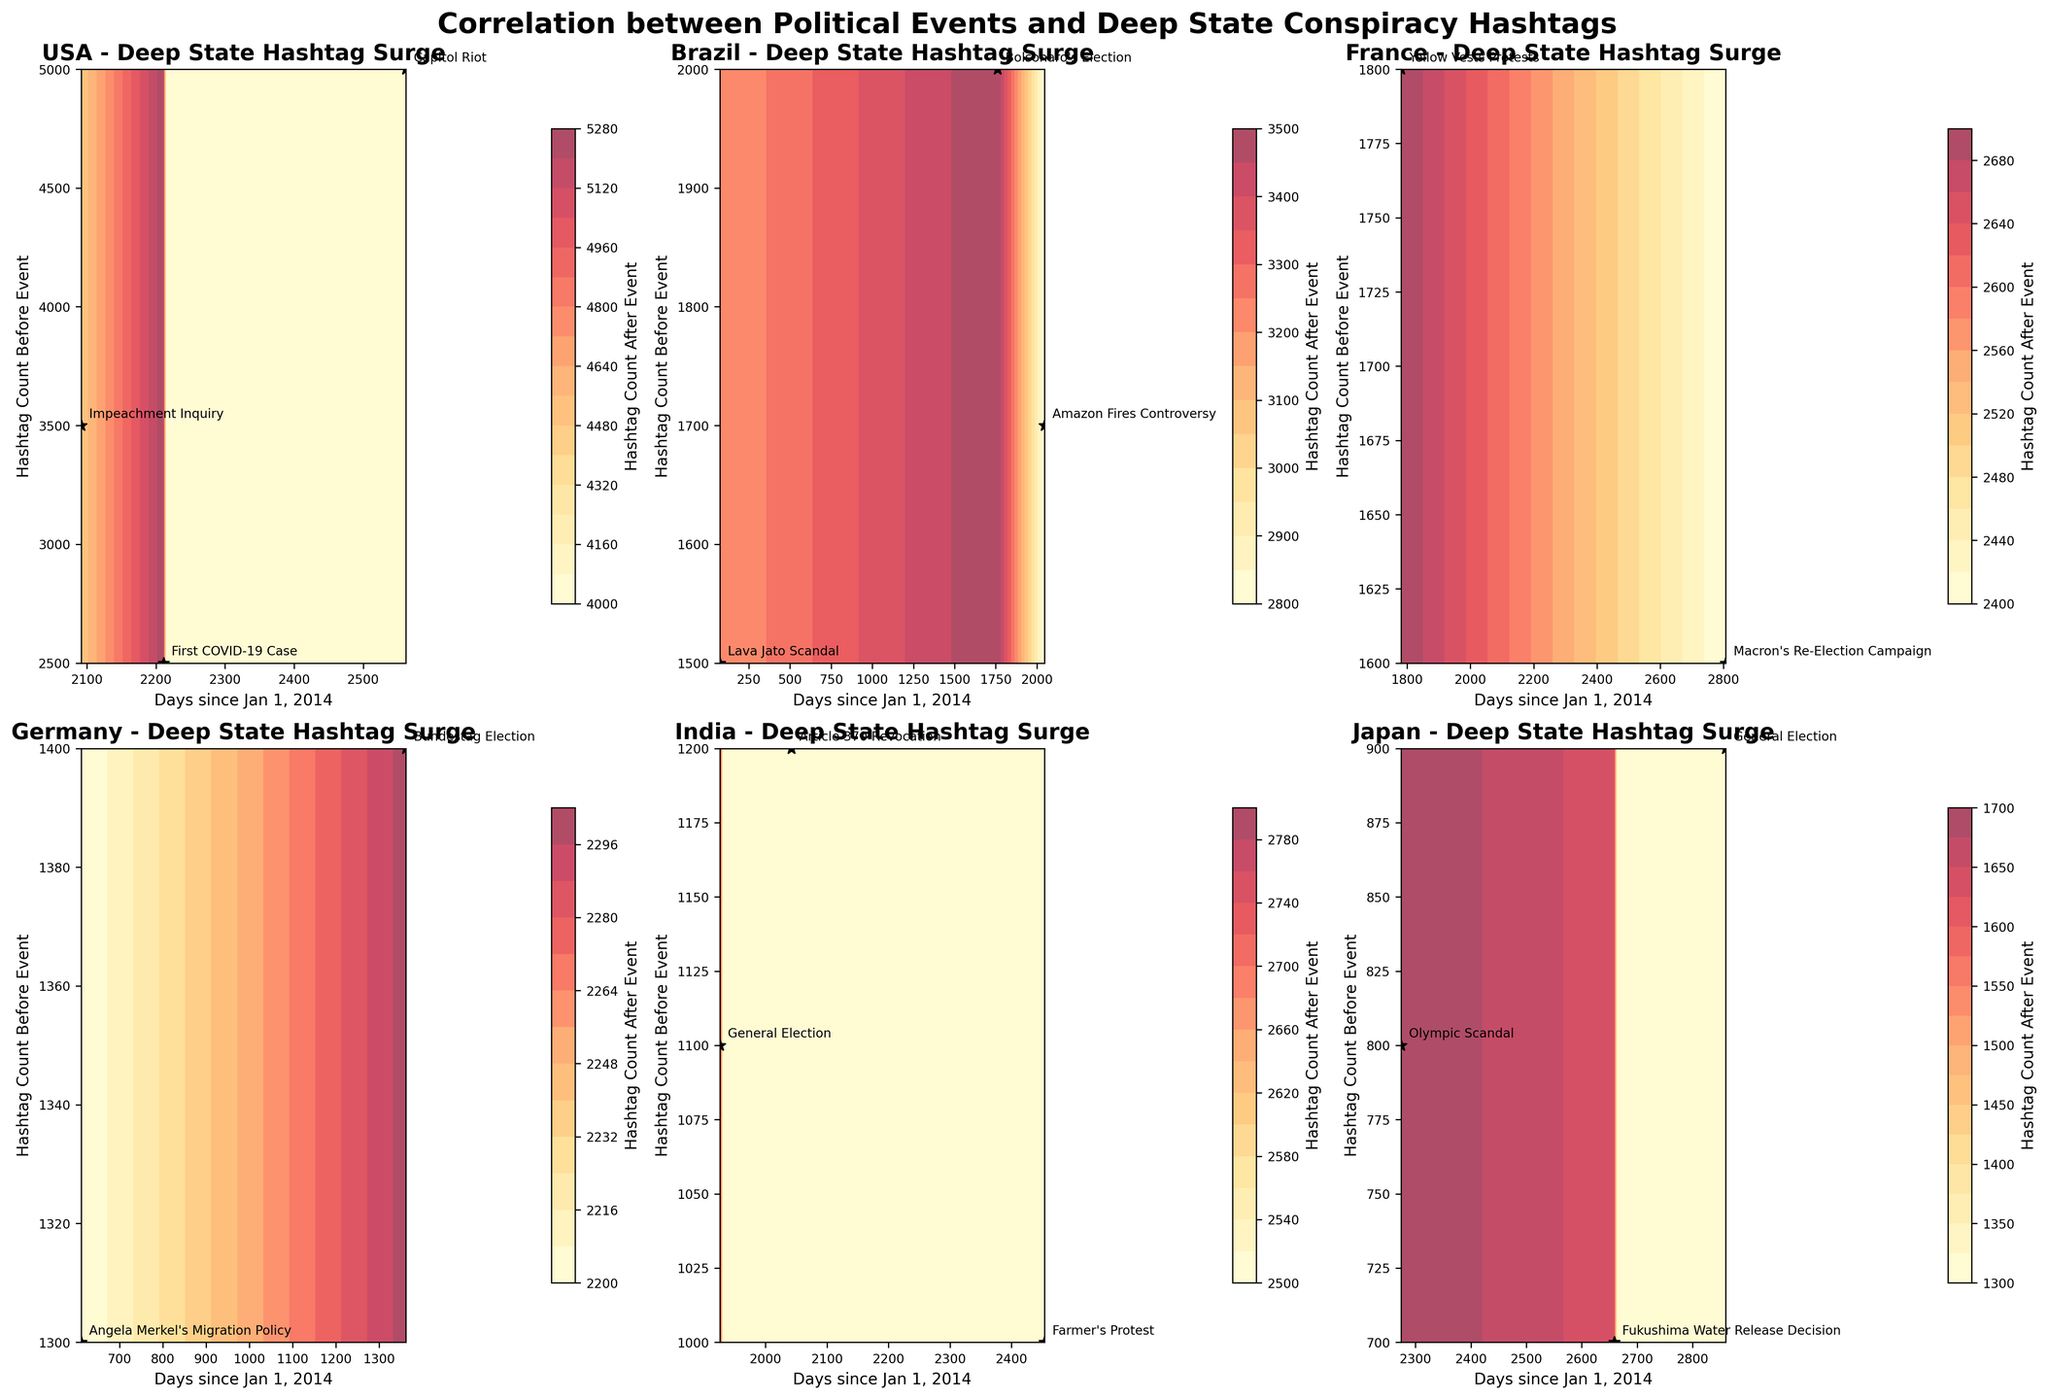How many countries are presented in the figure? The figure contains subplots for each country, and the subplot titles indicate the number of countries analyzed. By counting the titles, we determine how many countries are included.
Answer: 5 Which country shows the highest surge in hashtags after political events? By examining the color bar intensity and the scatter plots across all subplots, the country with the highest concentration of darker colors represents the highest surge in hashtags. The USA shows a significant increase in hashtag counts.
Answer: USA What is the color bar label in the figure? Each contour plot contains a color bar on the side. The label of the color bar indicates what values it represents. By reading the text next to the color bar, we can find the label.
Answer: Hashtag Count After Event Which political event in the USA subplot has the highest initial hashtag count before the event? In the USA subplot, identify the event with the largest y-axis value (Hashtag Count Before Event). The text annotations next to the highest point give the name of the political event.
Answer: Capitol Riot Comparing Brazil and France, which country had a greater range of days since January 1, 2014, when significant political events occurred? By comparing the ranges of the x-axes (Days since Jan 1, 2014) for Brazil and France subplots, the country with wider range of event dates can be determined.
Answer: Brazil What is the title of the figure? The title is located at the top center of the figure. By reading the text in this area, we can identify the title.
Answer: Correlation between Political Events and Deep State Conspiracy Hashtags Identify two countries with similar trends in hashtag counts before and after political events. Examine the contour plots and scatter points for trends where hashtag counts after events are proportionate to the counts before events for various countries. Countries with similar patterns of increases or stable counts before and after events can be identified.
Answer: France and Germany In the subplot for India, which event shows the smallest surge in hashtags after the event? By looking at the annotated political events and the corresponding points on the Y-axis (Hashtag Count Before Event) and checking the color intensity for changes after the event (color bar), we can identify the event with the smallest change.
Answer: General Election Which language is used the most frequently across the subplots? By reading the languages used in each subplot's title or the text annotations within each subplot, we count the occurrences of each language to find the most frequently used one.
Answer: English Comparing the contour density, which country had the most consistent increase in hashtags across all events? By observing the density of the contour lines and their uniformity in each subplot, the most consistent increase can be identified by the smoothness and even spread of contour lines.
Answer: Germany 